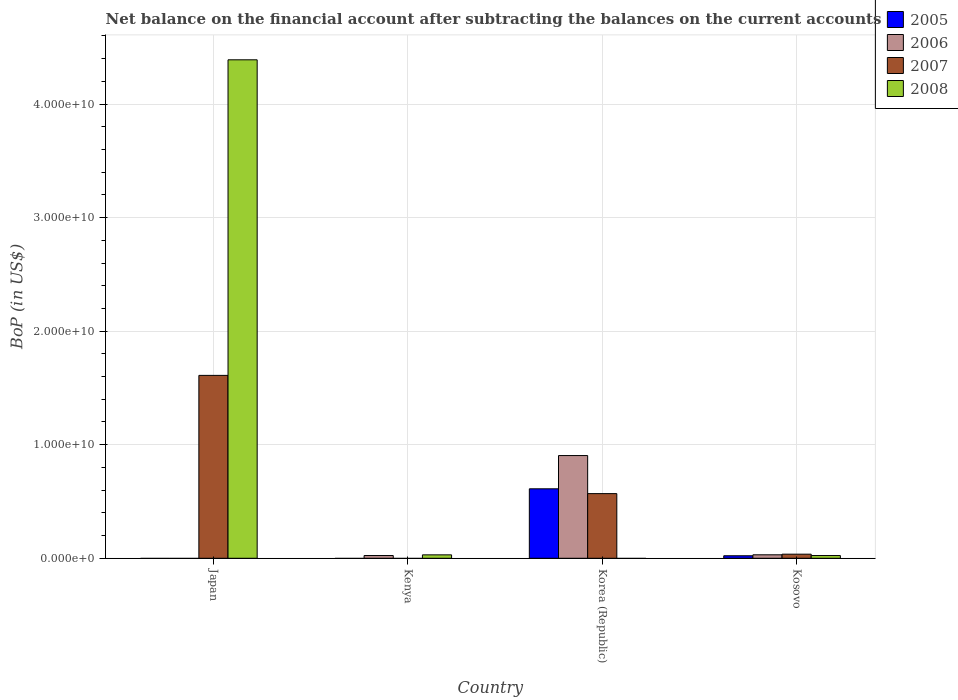How many different coloured bars are there?
Your response must be concise. 4. How many groups of bars are there?
Make the answer very short. 4. Are the number of bars per tick equal to the number of legend labels?
Your response must be concise. No. In how many cases, is the number of bars for a given country not equal to the number of legend labels?
Make the answer very short. 3. What is the Balance of Payments in 2007 in Japan?
Your answer should be compact. 1.61e+1. Across all countries, what is the maximum Balance of Payments in 2006?
Your response must be concise. 9.05e+09. Across all countries, what is the minimum Balance of Payments in 2006?
Provide a short and direct response. 0. In which country was the Balance of Payments in 2006 maximum?
Provide a succinct answer. Korea (Republic). What is the total Balance of Payments in 2007 in the graph?
Ensure brevity in your answer.  2.22e+1. What is the difference between the Balance of Payments in 2008 in Japan and that in Kosovo?
Provide a short and direct response. 4.37e+1. What is the difference between the Balance of Payments in 2005 in Kenya and the Balance of Payments in 2007 in Japan?
Keep it short and to the point. -1.61e+1. What is the average Balance of Payments in 2008 per country?
Your response must be concise. 1.11e+1. What is the difference between the Balance of Payments of/in 2007 and Balance of Payments of/in 2006 in Kosovo?
Make the answer very short. 5.55e+07. What is the ratio of the Balance of Payments in 2006 in Kenya to that in Korea (Republic)?
Ensure brevity in your answer.  0.03. Is the Balance of Payments in 2007 in Korea (Republic) less than that in Kosovo?
Your answer should be compact. No. What is the difference between the highest and the second highest Balance of Payments in 2006?
Your answer should be very brief. 8.74e+09. What is the difference between the highest and the lowest Balance of Payments in 2006?
Provide a short and direct response. 9.05e+09. In how many countries, is the Balance of Payments in 2007 greater than the average Balance of Payments in 2007 taken over all countries?
Your answer should be very brief. 2. Is the sum of the Balance of Payments in 2007 in Japan and Kosovo greater than the maximum Balance of Payments in 2008 across all countries?
Make the answer very short. No. Are all the bars in the graph horizontal?
Your answer should be compact. No. How many countries are there in the graph?
Your answer should be very brief. 4. Does the graph contain any zero values?
Make the answer very short. Yes. How many legend labels are there?
Offer a terse response. 4. How are the legend labels stacked?
Offer a very short reply. Vertical. What is the title of the graph?
Offer a terse response. Net balance on the financial account after subtracting the balances on the current accounts. Does "1984" appear as one of the legend labels in the graph?
Ensure brevity in your answer.  No. What is the label or title of the X-axis?
Keep it short and to the point. Country. What is the label or title of the Y-axis?
Make the answer very short. BoP (in US$). What is the BoP (in US$) of 2007 in Japan?
Offer a terse response. 1.61e+1. What is the BoP (in US$) in 2008 in Japan?
Ensure brevity in your answer.  4.39e+1. What is the BoP (in US$) in 2006 in Kenya?
Provide a succinct answer. 2.42e+08. What is the BoP (in US$) in 2007 in Kenya?
Keep it short and to the point. 0. What is the BoP (in US$) in 2008 in Kenya?
Give a very brief answer. 3.01e+08. What is the BoP (in US$) of 2005 in Korea (Republic)?
Your answer should be compact. 6.12e+09. What is the BoP (in US$) of 2006 in Korea (Republic)?
Your answer should be compact. 9.05e+09. What is the BoP (in US$) of 2007 in Korea (Republic)?
Offer a very short reply. 5.69e+09. What is the BoP (in US$) in 2005 in Kosovo?
Your response must be concise. 2.21e+08. What is the BoP (in US$) in 2006 in Kosovo?
Your answer should be compact. 3.05e+08. What is the BoP (in US$) of 2007 in Kosovo?
Ensure brevity in your answer.  3.60e+08. What is the BoP (in US$) in 2008 in Kosovo?
Give a very brief answer. 2.41e+08. Across all countries, what is the maximum BoP (in US$) in 2005?
Give a very brief answer. 6.12e+09. Across all countries, what is the maximum BoP (in US$) in 2006?
Provide a short and direct response. 9.05e+09. Across all countries, what is the maximum BoP (in US$) of 2007?
Make the answer very short. 1.61e+1. Across all countries, what is the maximum BoP (in US$) of 2008?
Make the answer very short. 4.39e+1. Across all countries, what is the minimum BoP (in US$) in 2006?
Your response must be concise. 0. Across all countries, what is the minimum BoP (in US$) in 2007?
Your answer should be compact. 0. What is the total BoP (in US$) of 2005 in the graph?
Give a very brief answer. 6.34e+09. What is the total BoP (in US$) in 2006 in the graph?
Keep it short and to the point. 9.59e+09. What is the total BoP (in US$) of 2007 in the graph?
Keep it short and to the point. 2.22e+1. What is the total BoP (in US$) in 2008 in the graph?
Your response must be concise. 4.44e+1. What is the difference between the BoP (in US$) in 2008 in Japan and that in Kenya?
Ensure brevity in your answer.  4.36e+1. What is the difference between the BoP (in US$) of 2007 in Japan and that in Korea (Republic)?
Keep it short and to the point. 1.04e+1. What is the difference between the BoP (in US$) in 2007 in Japan and that in Kosovo?
Offer a terse response. 1.57e+1. What is the difference between the BoP (in US$) of 2008 in Japan and that in Kosovo?
Your answer should be compact. 4.37e+1. What is the difference between the BoP (in US$) of 2006 in Kenya and that in Korea (Republic)?
Your response must be concise. -8.80e+09. What is the difference between the BoP (in US$) in 2006 in Kenya and that in Kosovo?
Your response must be concise. -6.26e+07. What is the difference between the BoP (in US$) of 2008 in Kenya and that in Kosovo?
Offer a very short reply. 5.99e+07. What is the difference between the BoP (in US$) of 2005 in Korea (Republic) and that in Kosovo?
Keep it short and to the point. 5.90e+09. What is the difference between the BoP (in US$) of 2006 in Korea (Republic) and that in Kosovo?
Your response must be concise. 8.74e+09. What is the difference between the BoP (in US$) in 2007 in Korea (Republic) and that in Kosovo?
Offer a terse response. 5.33e+09. What is the difference between the BoP (in US$) in 2007 in Japan and the BoP (in US$) in 2008 in Kenya?
Give a very brief answer. 1.58e+1. What is the difference between the BoP (in US$) in 2007 in Japan and the BoP (in US$) in 2008 in Kosovo?
Provide a short and direct response. 1.59e+1. What is the difference between the BoP (in US$) of 2006 in Kenya and the BoP (in US$) of 2007 in Korea (Republic)?
Provide a succinct answer. -5.45e+09. What is the difference between the BoP (in US$) in 2006 in Kenya and the BoP (in US$) in 2007 in Kosovo?
Ensure brevity in your answer.  -1.18e+08. What is the difference between the BoP (in US$) of 2006 in Kenya and the BoP (in US$) of 2008 in Kosovo?
Provide a short and direct response. 1.71e+06. What is the difference between the BoP (in US$) in 2005 in Korea (Republic) and the BoP (in US$) in 2006 in Kosovo?
Your response must be concise. 5.81e+09. What is the difference between the BoP (in US$) of 2005 in Korea (Republic) and the BoP (in US$) of 2007 in Kosovo?
Give a very brief answer. 5.76e+09. What is the difference between the BoP (in US$) in 2005 in Korea (Republic) and the BoP (in US$) in 2008 in Kosovo?
Provide a succinct answer. 5.88e+09. What is the difference between the BoP (in US$) in 2006 in Korea (Republic) and the BoP (in US$) in 2007 in Kosovo?
Provide a short and direct response. 8.68e+09. What is the difference between the BoP (in US$) of 2006 in Korea (Republic) and the BoP (in US$) of 2008 in Kosovo?
Your response must be concise. 8.80e+09. What is the difference between the BoP (in US$) of 2007 in Korea (Republic) and the BoP (in US$) of 2008 in Kosovo?
Your response must be concise. 5.45e+09. What is the average BoP (in US$) of 2005 per country?
Your response must be concise. 1.58e+09. What is the average BoP (in US$) of 2006 per country?
Give a very brief answer. 2.40e+09. What is the average BoP (in US$) in 2007 per country?
Give a very brief answer. 5.54e+09. What is the average BoP (in US$) of 2008 per country?
Offer a very short reply. 1.11e+1. What is the difference between the BoP (in US$) in 2007 and BoP (in US$) in 2008 in Japan?
Give a very brief answer. -2.78e+1. What is the difference between the BoP (in US$) of 2006 and BoP (in US$) of 2008 in Kenya?
Ensure brevity in your answer.  -5.82e+07. What is the difference between the BoP (in US$) in 2005 and BoP (in US$) in 2006 in Korea (Republic)?
Provide a succinct answer. -2.93e+09. What is the difference between the BoP (in US$) in 2005 and BoP (in US$) in 2007 in Korea (Republic)?
Keep it short and to the point. 4.23e+08. What is the difference between the BoP (in US$) in 2006 and BoP (in US$) in 2007 in Korea (Republic)?
Offer a very short reply. 3.35e+09. What is the difference between the BoP (in US$) in 2005 and BoP (in US$) in 2006 in Kosovo?
Your answer should be very brief. -8.37e+07. What is the difference between the BoP (in US$) in 2005 and BoP (in US$) in 2007 in Kosovo?
Provide a short and direct response. -1.39e+08. What is the difference between the BoP (in US$) of 2005 and BoP (in US$) of 2008 in Kosovo?
Provide a succinct answer. -1.93e+07. What is the difference between the BoP (in US$) in 2006 and BoP (in US$) in 2007 in Kosovo?
Provide a succinct answer. -5.55e+07. What is the difference between the BoP (in US$) of 2006 and BoP (in US$) of 2008 in Kosovo?
Offer a terse response. 6.44e+07. What is the difference between the BoP (in US$) in 2007 and BoP (in US$) in 2008 in Kosovo?
Your response must be concise. 1.20e+08. What is the ratio of the BoP (in US$) in 2008 in Japan to that in Kenya?
Provide a short and direct response. 146.06. What is the ratio of the BoP (in US$) in 2007 in Japan to that in Korea (Republic)?
Provide a short and direct response. 2.83. What is the ratio of the BoP (in US$) in 2007 in Japan to that in Kosovo?
Offer a very short reply. 44.68. What is the ratio of the BoP (in US$) of 2008 in Japan to that in Kosovo?
Keep it short and to the point. 182.45. What is the ratio of the BoP (in US$) in 2006 in Kenya to that in Korea (Republic)?
Ensure brevity in your answer.  0.03. What is the ratio of the BoP (in US$) of 2006 in Kenya to that in Kosovo?
Offer a terse response. 0.79. What is the ratio of the BoP (in US$) in 2008 in Kenya to that in Kosovo?
Keep it short and to the point. 1.25. What is the ratio of the BoP (in US$) of 2005 in Korea (Republic) to that in Kosovo?
Your answer should be very brief. 27.65. What is the ratio of the BoP (in US$) in 2006 in Korea (Republic) to that in Kosovo?
Your answer should be very brief. 29.66. What is the ratio of the BoP (in US$) in 2007 in Korea (Republic) to that in Kosovo?
Your answer should be very brief. 15.8. What is the difference between the highest and the second highest BoP (in US$) of 2006?
Provide a short and direct response. 8.74e+09. What is the difference between the highest and the second highest BoP (in US$) in 2007?
Give a very brief answer. 1.04e+1. What is the difference between the highest and the second highest BoP (in US$) in 2008?
Provide a succinct answer. 4.36e+1. What is the difference between the highest and the lowest BoP (in US$) in 2005?
Offer a terse response. 6.12e+09. What is the difference between the highest and the lowest BoP (in US$) of 2006?
Keep it short and to the point. 9.05e+09. What is the difference between the highest and the lowest BoP (in US$) in 2007?
Offer a terse response. 1.61e+1. What is the difference between the highest and the lowest BoP (in US$) of 2008?
Ensure brevity in your answer.  4.39e+1. 